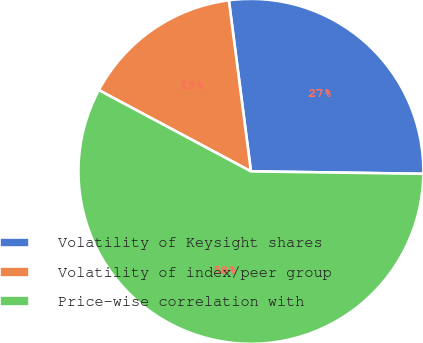Convert chart to OTSL. <chart><loc_0><loc_0><loc_500><loc_500><pie_chart><fcel>Volatility of Keysight shares<fcel>Volatility of index/peer group<fcel>Price-wise correlation with<nl><fcel>27.27%<fcel>15.15%<fcel>57.58%<nl></chart> 